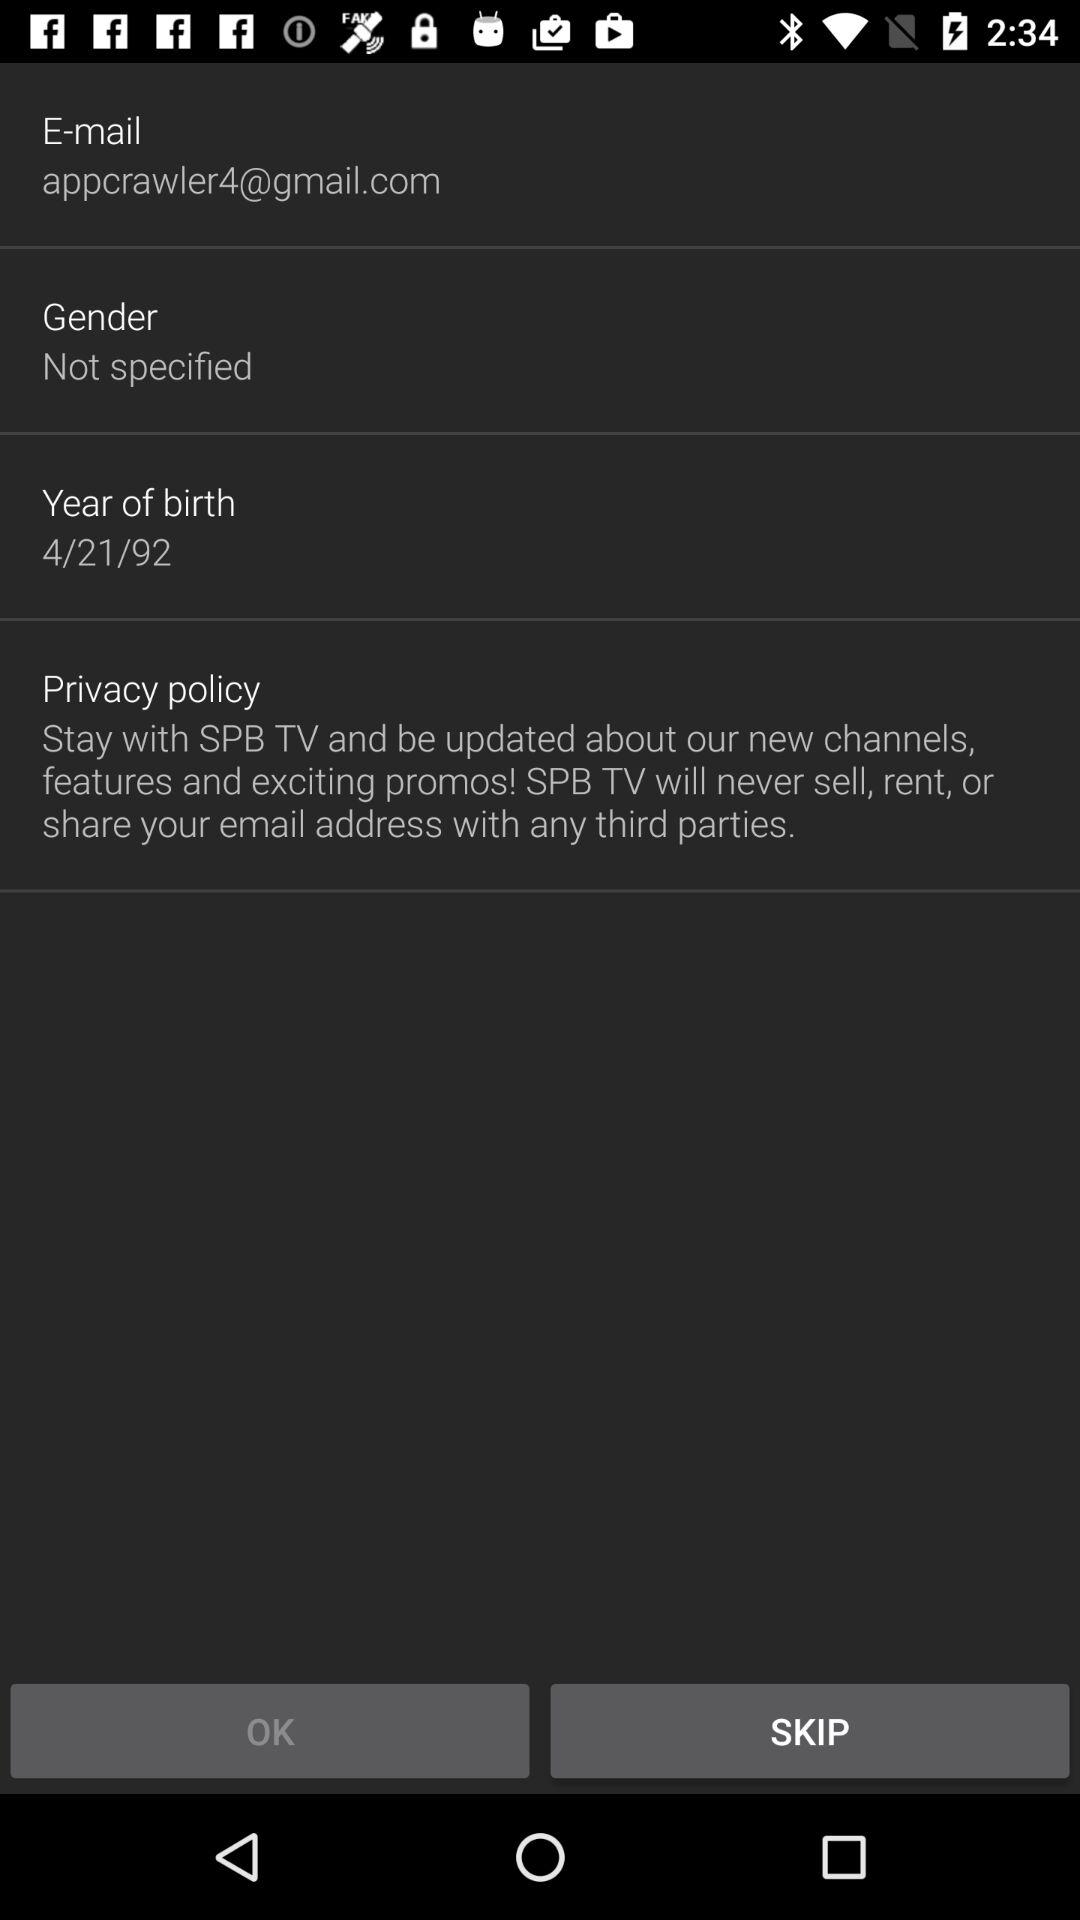What is the email address? The email address is appcrawler4@gmail.com. 